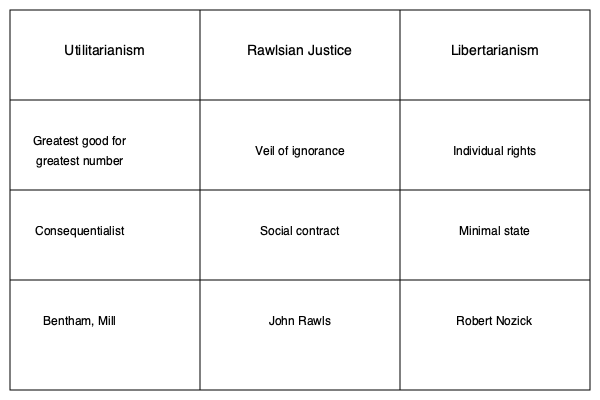Based on the comparative chart of justice theories, which approach emphasizes the concept of a "veil of ignorance" and is associated with a social contract perspective? To answer this question, we need to analyze the information provided in the comparative chart of justice theories. Let's break it down step-by-step:

1. The chart compares three major theories of justice: Utilitarianism, Rawlsian Justice, and Libertarianism.

2. For each theory, the chart provides key concepts, approaches, and associated philosophers.

3. Looking at the second row of the chart, we can see that the "veil of ignorance" is listed under the Rawlsian Justice column.

4. In the third row, we find that Rawlsian Justice is associated with a "social contract" approach.

5. The question asks specifically about an approach that emphasizes the "veil of ignorance" and is associated with a social contract perspective.

6. Both of these characteristics align with the Rawlsian Justice theory as presented in the chart.

7. Additionally, we can see that John Rawls is listed as the key philosopher associated with this theory in the bottom row of the chart.

Therefore, based on the information provided in the comparative chart, the approach that emphasizes the concept of a "veil of ignorance" and is associated with a social contract perspective is Rawlsian Justice.
Answer: Rawlsian Justice 